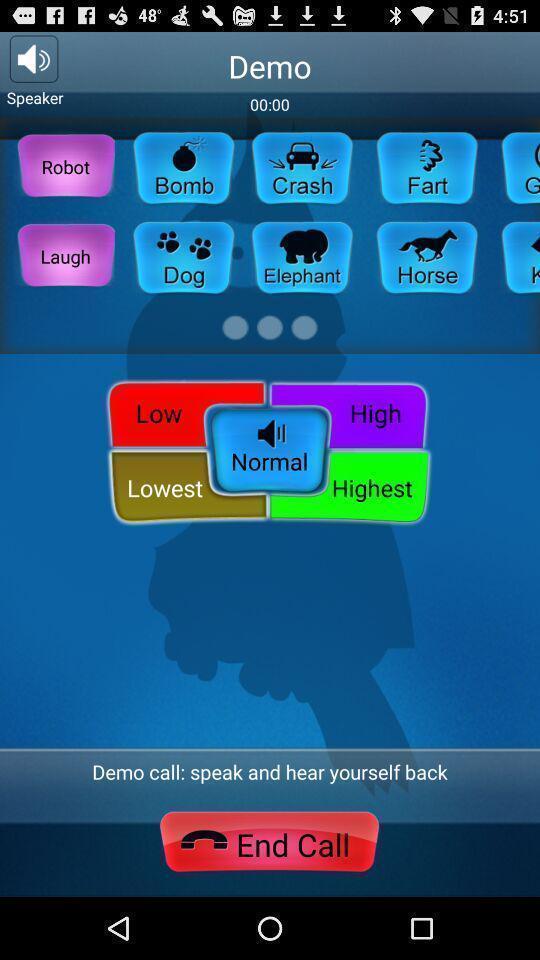Describe this image in words. Screen displaying the demo call. 